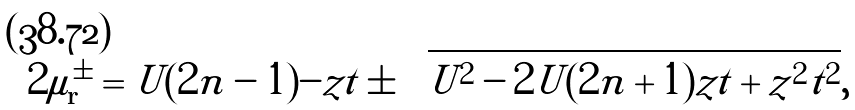<formula> <loc_0><loc_0><loc_500><loc_500>2 \mu _ { \mathbf r } ^ { \pm } = U ( 2 n - 1 ) - z t \pm \sqrt { U ^ { 2 } - 2 U ( 2 n + 1 ) z t + z ^ { 2 } t ^ { 2 } } ,</formula> 